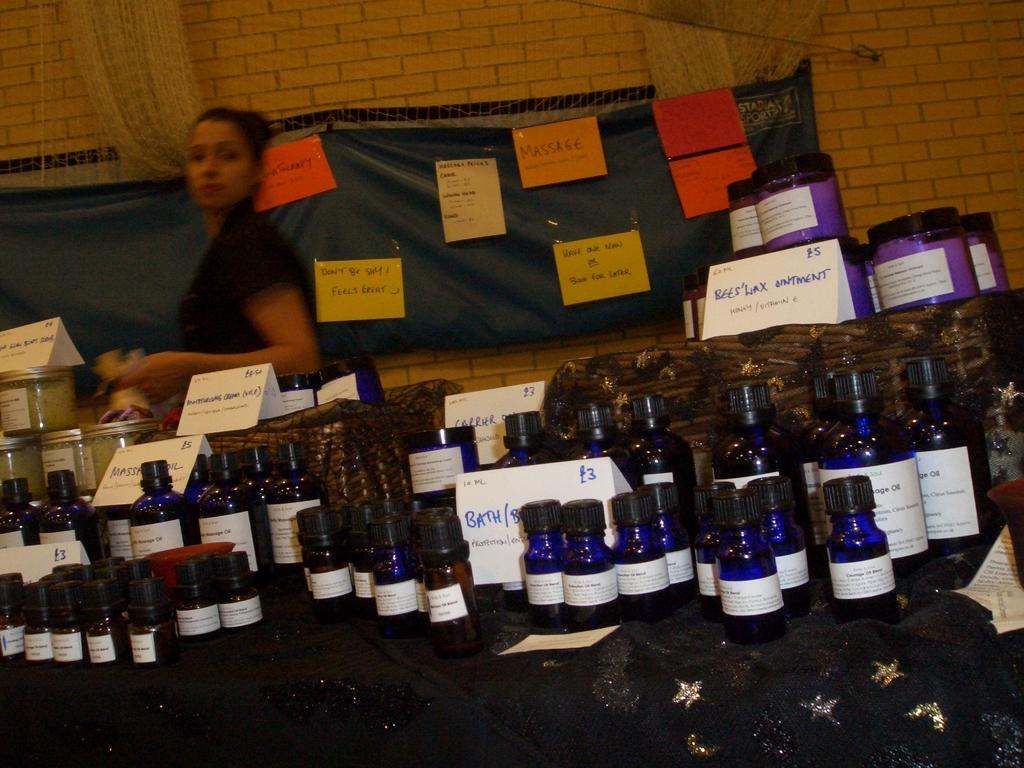Provide a one-sentence caption for the provided image. A woman stands behind a table with many bottles for sale, including Beeswax Ointment and Moisturizing Cream. 